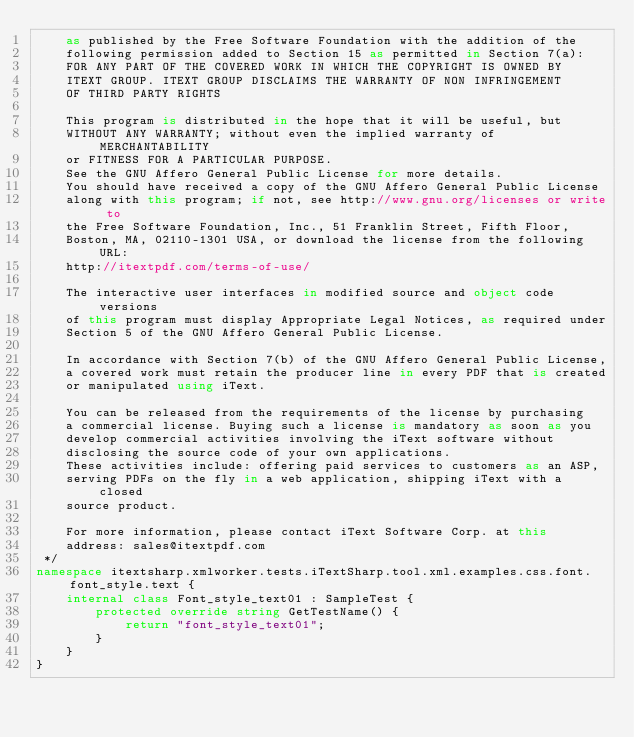Convert code to text. <code><loc_0><loc_0><loc_500><loc_500><_C#_>    as published by the Free Software Foundation with the addition of the
    following permission added to Section 15 as permitted in Section 7(a):
    FOR ANY PART OF THE COVERED WORK IN WHICH THE COPYRIGHT IS OWNED BY
    ITEXT GROUP. ITEXT GROUP DISCLAIMS THE WARRANTY OF NON INFRINGEMENT
    OF THIRD PARTY RIGHTS
    
    This program is distributed in the hope that it will be useful, but
    WITHOUT ANY WARRANTY; without even the implied warranty of MERCHANTABILITY
    or FITNESS FOR A PARTICULAR PURPOSE.
    See the GNU Affero General Public License for more details.
    You should have received a copy of the GNU Affero General Public License
    along with this program; if not, see http://www.gnu.org/licenses or write to
    the Free Software Foundation, Inc., 51 Franklin Street, Fifth Floor,
    Boston, MA, 02110-1301 USA, or download the license from the following URL:
    http://itextpdf.com/terms-of-use/
    
    The interactive user interfaces in modified source and object code versions
    of this program must display Appropriate Legal Notices, as required under
    Section 5 of the GNU Affero General Public License.
    
    In accordance with Section 7(b) of the GNU Affero General Public License,
    a covered work must retain the producer line in every PDF that is created
    or manipulated using iText.
    
    You can be released from the requirements of the license by purchasing
    a commercial license. Buying such a license is mandatory as soon as you
    develop commercial activities involving the iText software without
    disclosing the source code of your own applications.
    These activities include: offering paid services to customers as an ASP,
    serving PDFs on the fly in a web application, shipping iText with a closed
    source product.
    
    For more information, please contact iText Software Corp. at this
    address: sales@itextpdf.com
 */
namespace itextsharp.xmlworker.tests.iTextSharp.tool.xml.examples.css.font.font_style.text {
    internal class Font_style_text01 : SampleTest {
        protected override string GetTestName() {
            return "font_style_text01";
        }
    }
}
</code> 